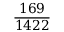<formula> <loc_0><loc_0><loc_500><loc_500>\frac { 1 6 9 } { 1 4 2 2 }</formula> 